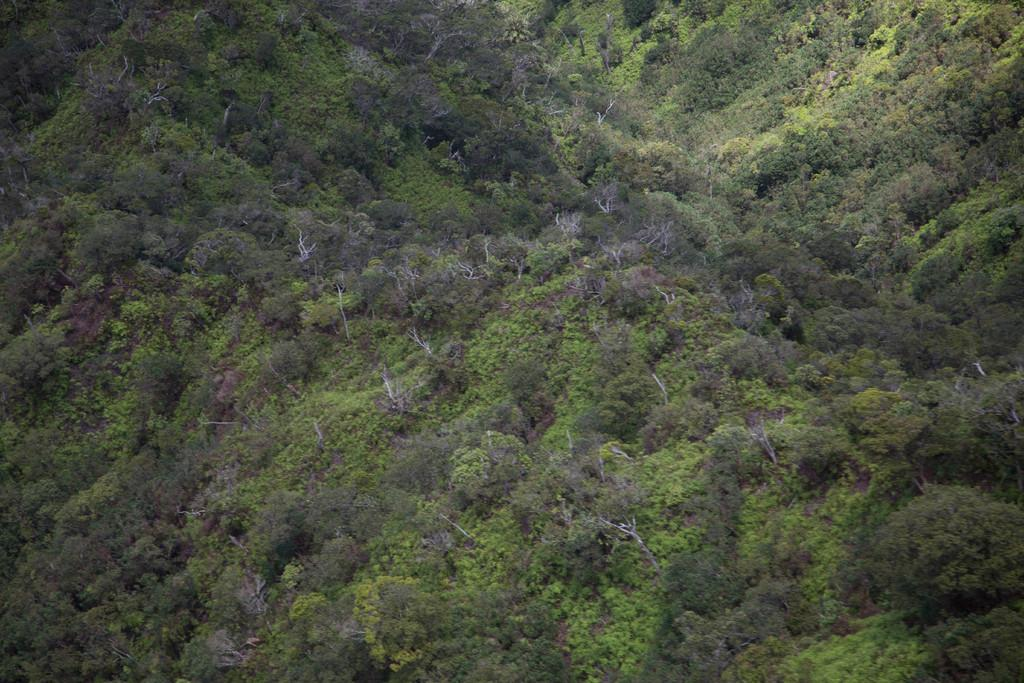What type of vegetation is present in the image? There are trees and plants in the image. Where are the trees and plants located? The trees and plants are on the ground in the image. What type of arch can be seen in the image? There is no arch present in the image; it features trees and plants on the ground. 